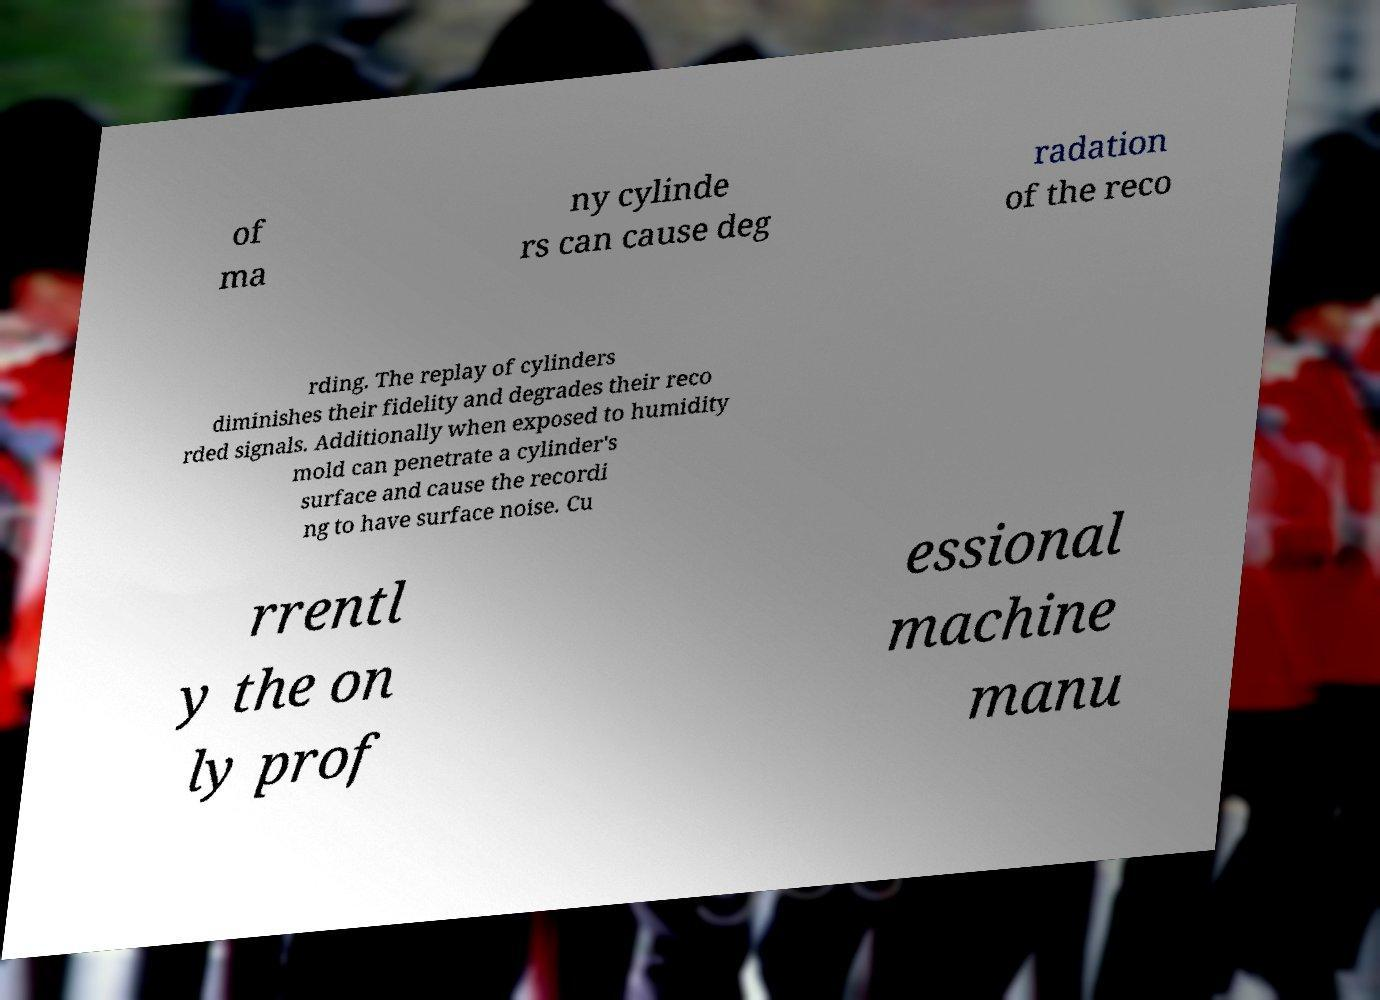Could you extract and type out the text from this image? of ma ny cylinde rs can cause deg radation of the reco rding. The replay of cylinders diminishes their fidelity and degrades their reco rded signals. Additionally when exposed to humidity mold can penetrate a cylinder's surface and cause the recordi ng to have surface noise. Cu rrentl y the on ly prof essional machine manu 